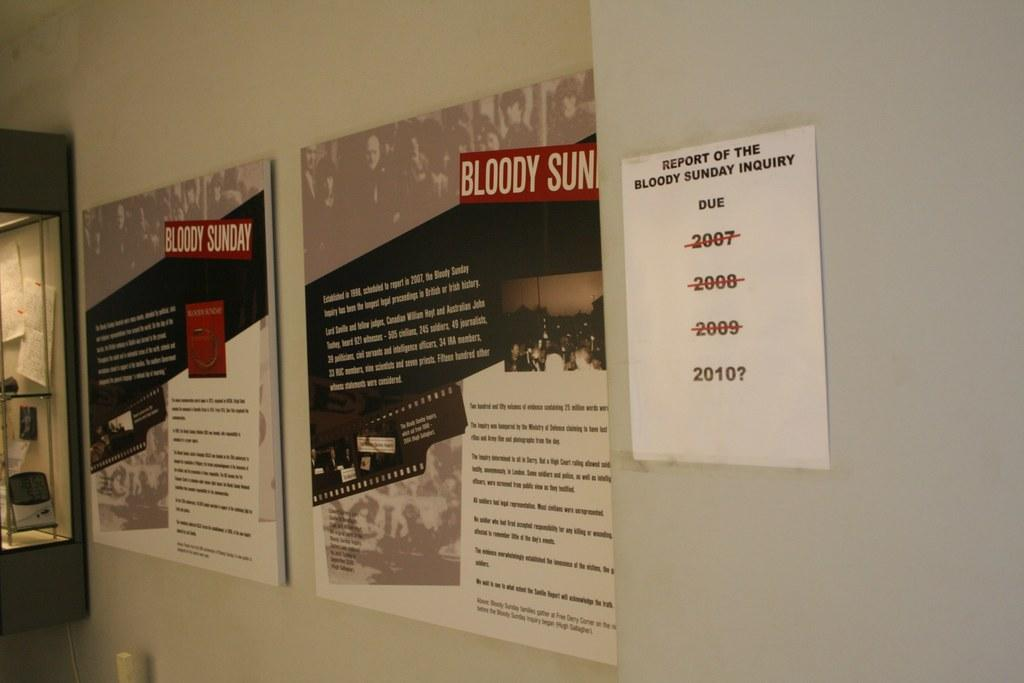<image>
Summarize the visual content of the image. Two posters advertising "Bloody Sunday" are on a tan wall. 